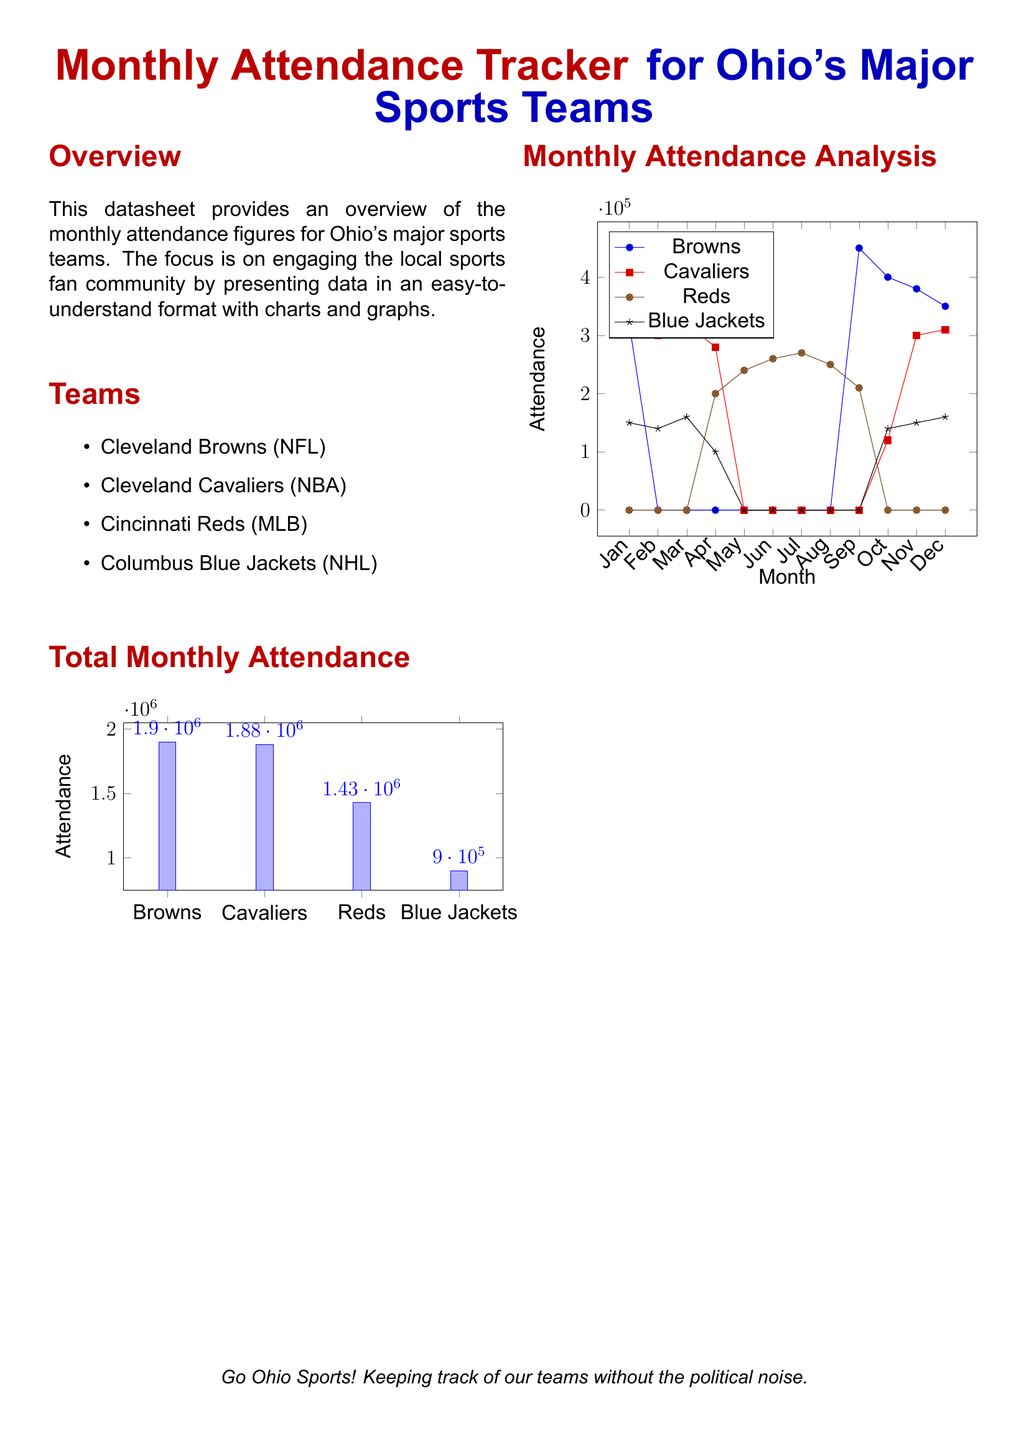What is the total attendance for the Cleveland Browns? The total attendance for the Cleveland Browns is shown in the attendance tracker, which is 1,900,000.
Answer: 1,900,000 Which team had the highest monthly attendance? The comparison of attendance figures in the charts shows that the Cleveland Browns had the highest attendance with 1,900,000.
Answer: Cleveland Browns How many teams are listed in the overview? The overview lists four major sports teams in Ohio, which is counted from the document.
Answer: 4 What was the attendance for the Columbus Blue Jackets in January? The chart represents the data where the attendance for the Columbus Blue Jackets in January is indicated as 150,000.
Answer: 150,000 During which month did the Cleveland Browns have the highest attendance? The data from the monthly attendance analysis indicates that the Cleveland Browns had the highest attendance in September with 450,000.
Answer: September What was the total attendance for the Cleveland Cavaliers? The attendance figure for the Cleveland Cavaliers is clearly stated in the document, amounting to 1,880,000.
Answer: 1,880,000 Which month had zero attendance for the Cincinnati Reds? The monthly chart shows that the Cincinnati Reds had zero attendance during multiple months, particularly in the first two months.
Answer: January What color represents Ohio's major sports teams in the document? The primary colors in the document representing Ohio's teams are defined, including ohiored and ohioblue.
Answer: Ohiored and Ohioblue 